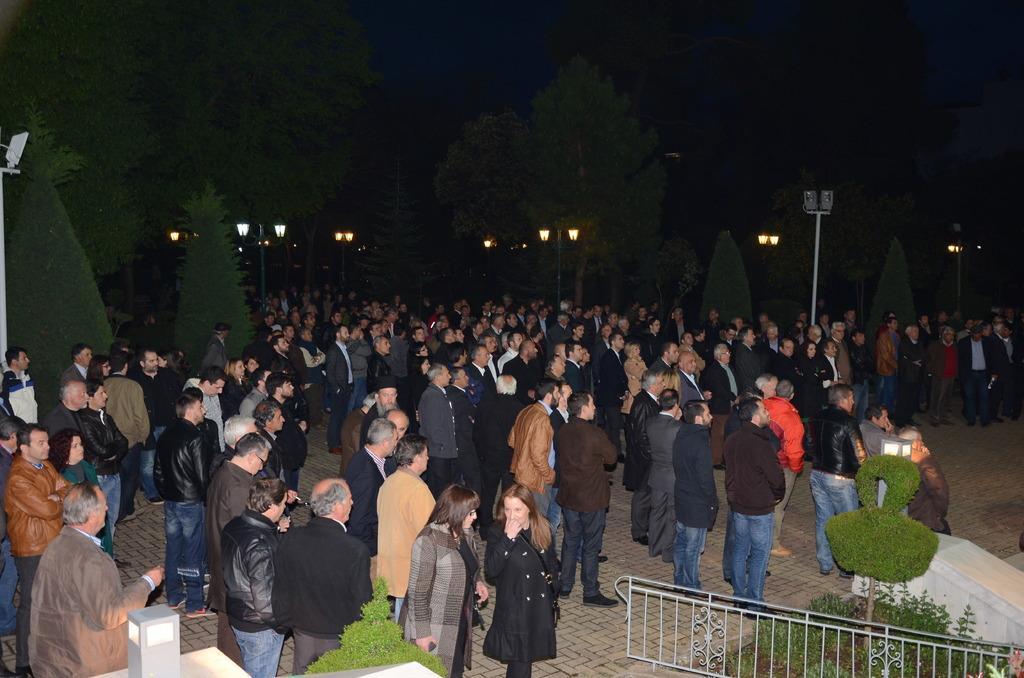How would you summarize this image in a sentence or two? In the center of the image there are people standing. In the background of the image there are light poles,trees. At the bottom of the image there is a gate. There are plants. 